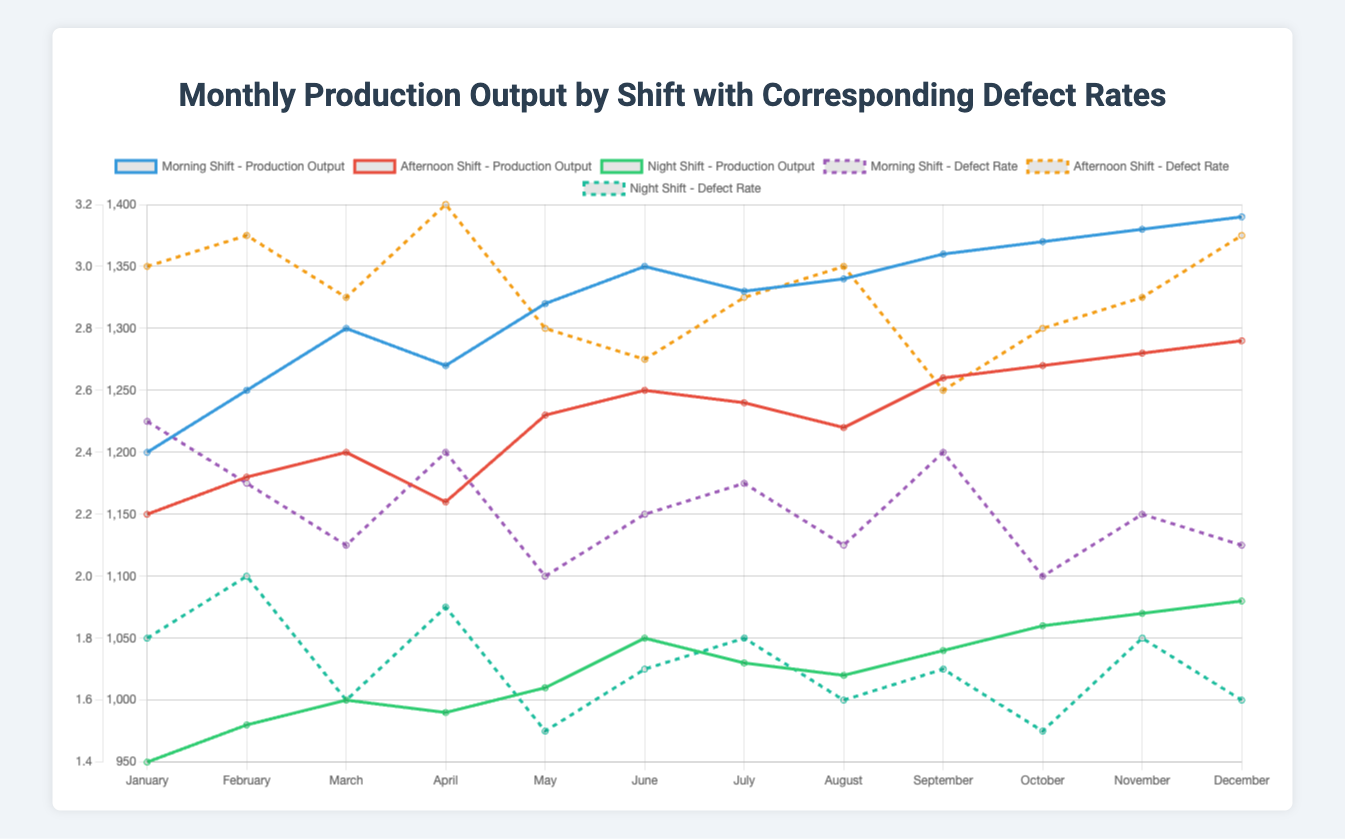What's the overall trend for the morning shift's production output from January to December? To determine the overall trend, we need to observe the morning shift's production outputs month by month. From January (1200) to December (1390), the production generally increases with some fluctuations. Hence, the overall trend is increasing.
Answer: Increasing In which month does the night shift have the highest defect rate, and what is the rate? We need to identify the defect rates for the night shift in each month and find the maximum value. The highest defect rate for the night shift occurs in April with a rate of 1.9%.
Answer: April, 1.9% Which shift has the most consistent defect rate over the year, and how do you determine this? Examine the variation in defect rates for each shift from January to December. Compared to the morning and afternoon shifts, the night shift has defect rates ranging narrowly from 1.5% to 1.9%, implying consistency.
Answer: Night Shift What is the difference in production output between the morning and night shifts in December? Extract the production outputs for both shifts in December: morning (1390) and night (1080). The difference is 1390 - 1080 = 310.
Answer: 310 Which month shows the highest average production output across all shifts? Calculate the average production output for each month by summing all shifts' outputs and dividing by three. October (1370+1270+1060) / 3 = 1233.33, topping other months.
Answer: October How does the afternoon shift's defect rate in June compare to that in September? Compare the defect rates from June (2.7%) and September (2.6%). June has a slightly higher defect rate than September.
Answer: June higher What visual cue indicates the defect rates for each shift? The defect rates are represented by dashed lines with different colors. The morning shift's defect rate is purple, the afternoon shift's is orange, and the night shift's is teal.
Answer: Dashed lines with different colors During which month does the afternoon shift experience its lowest production output and what is the output amount? Identify the month with the minimum production output for the afternoon shift. April has the lowest output at 1160.
Answer: April, 1160 Compare the morning shift's defect rate in January to the night shift's defect rate in January. Which is higher and by how much? The morning shift’s defect rate in January is 2.5%, and the night shift’s is 1.8%. The morning shift’s defect rate is higher by 2.5% - 1.8% = 0.7%.
Answer: Morning, 0.7% What is the average defect rate for the afternoon shift over the year? Sum the defect rates for each month for the afternoon shift and divide by 12: (3.0 + 3.1 + 2.9 + 3.2 + 2.8 + 2.7 + 2.9 + 3.0 + 2.6 + 2.8 + 2.9 + 3.1) / 12 = 2.9333%.
Answer: 2.9333% 